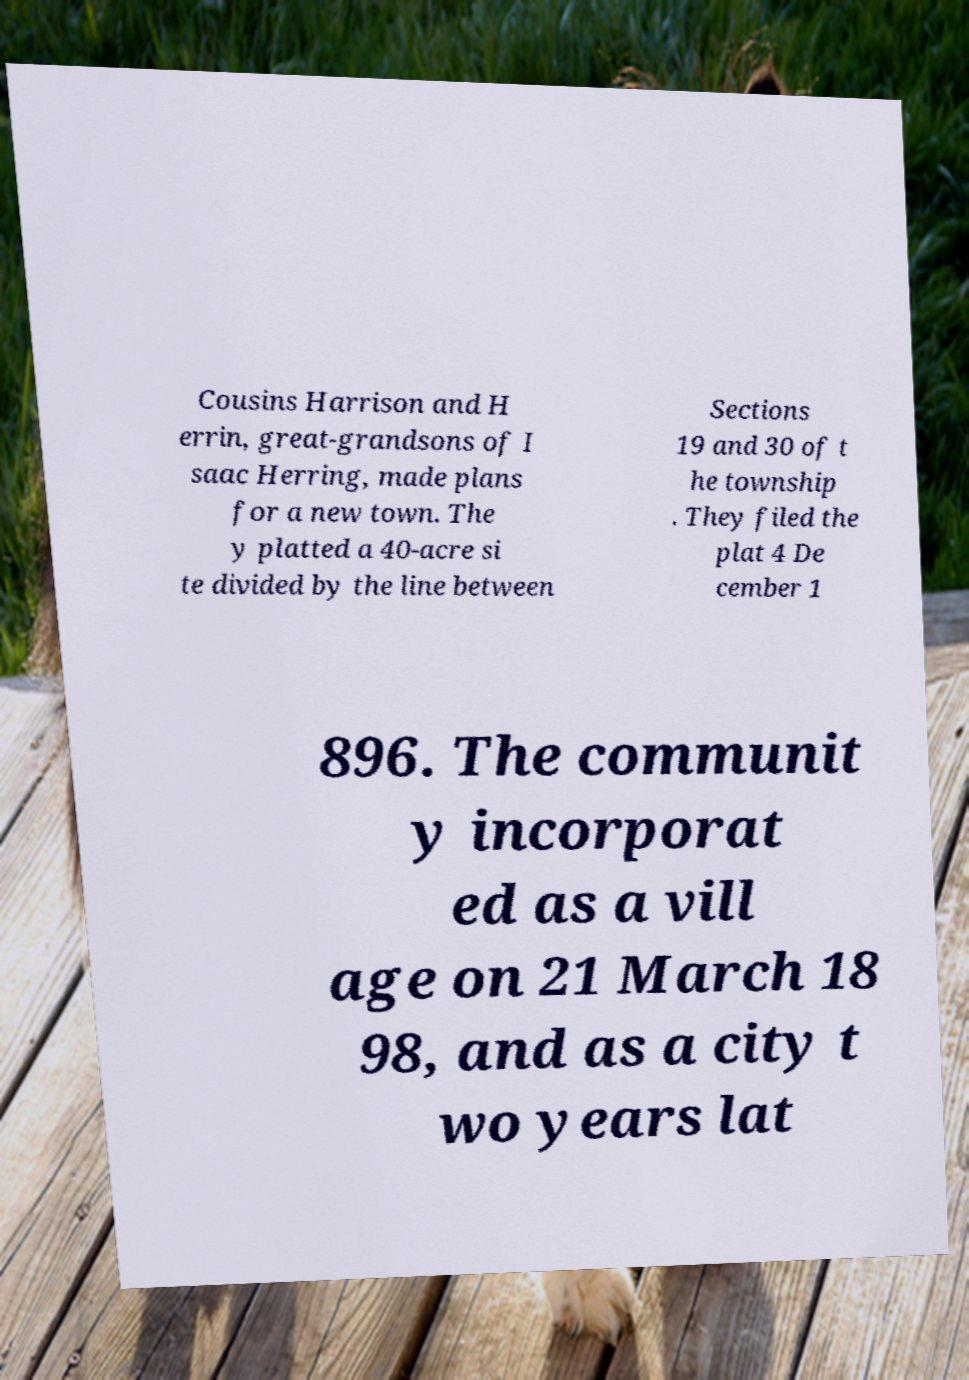Could you assist in decoding the text presented in this image and type it out clearly? Cousins Harrison and H errin, great-grandsons of I saac Herring, made plans for a new town. The y platted a 40-acre si te divided by the line between Sections 19 and 30 of t he township . They filed the plat 4 De cember 1 896. The communit y incorporat ed as a vill age on 21 March 18 98, and as a city t wo years lat 